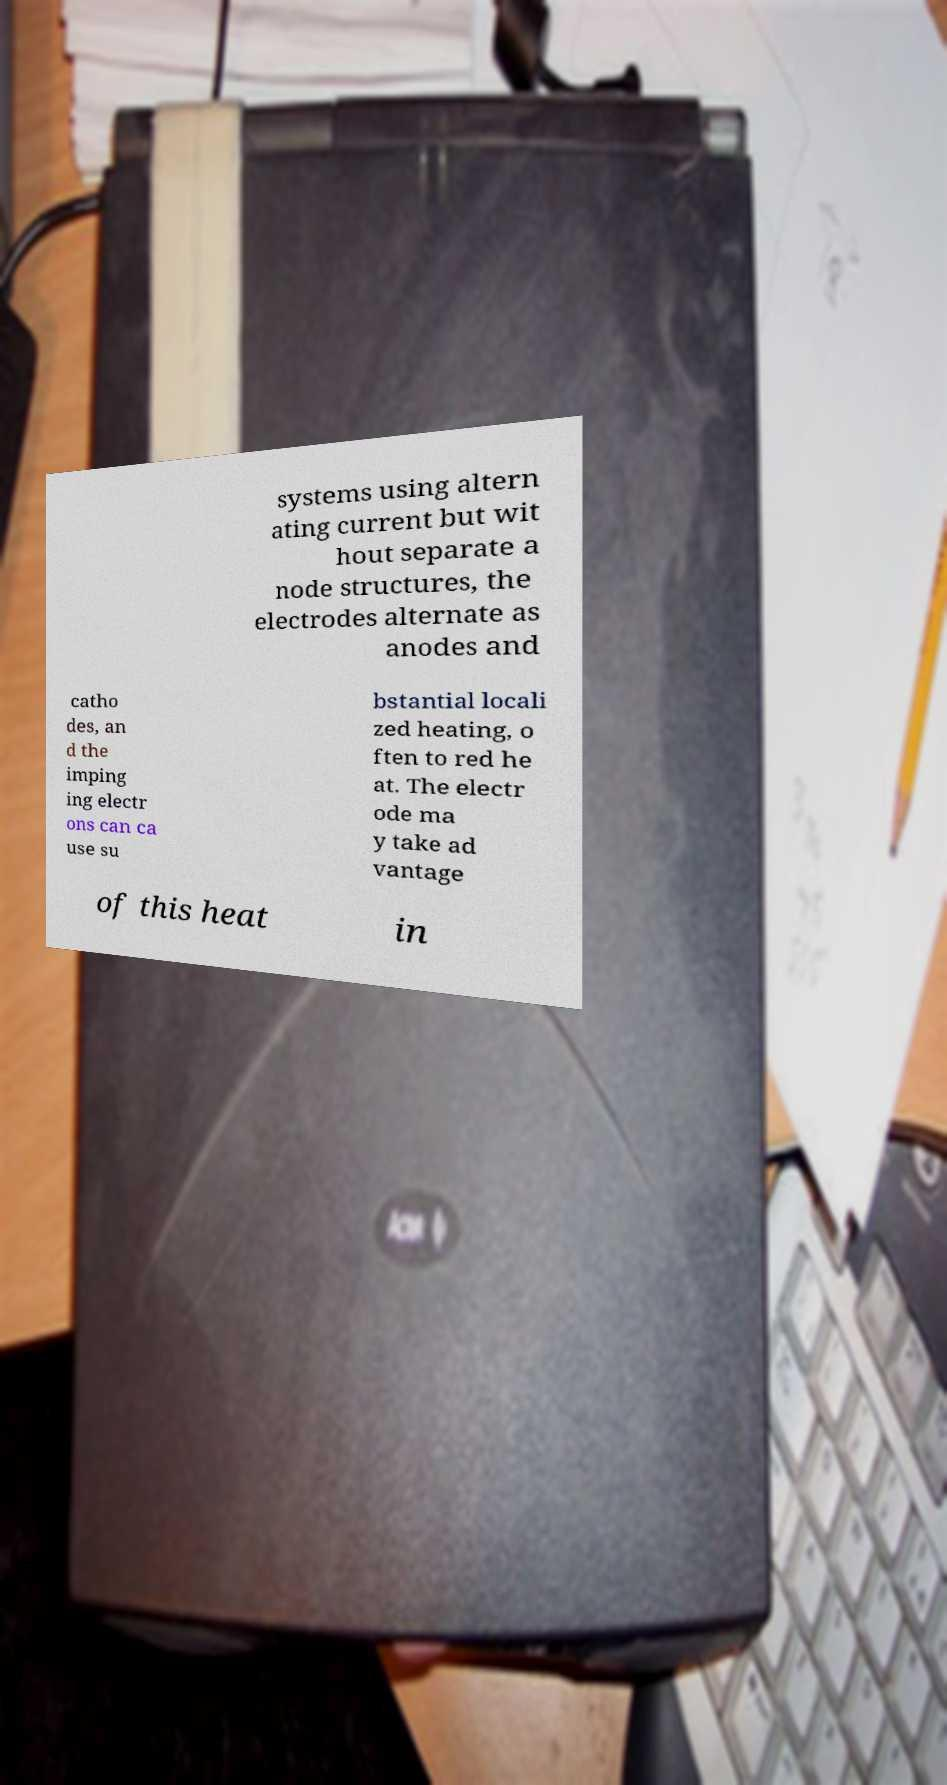Please identify and transcribe the text found in this image. systems using altern ating current but wit hout separate a node structures, the electrodes alternate as anodes and catho des, an d the imping ing electr ons can ca use su bstantial locali zed heating, o ften to red he at. The electr ode ma y take ad vantage of this heat in 